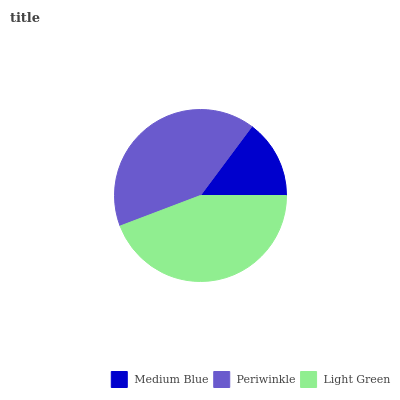Is Medium Blue the minimum?
Answer yes or no. Yes. Is Light Green the maximum?
Answer yes or no. Yes. Is Periwinkle the minimum?
Answer yes or no. No. Is Periwinkle the maximum?
Answer yes or no. No. Is Periwinkle greater than Medium Blue?
Answer yes or no. Yes. Is Medium Blue less than Periwinkle?
Answer yes or no. Yes. Is Medium Blue greater than Periwinkle?
Answer yes or no. No. Is Periwinkle less than Medium Blue?
Answer yes or no. No. Is Periwinkle the high median?
Answer yes or no. Yes. Is Periwinkle the low median?
Answer yes or no. Yes. Is Light Green the high median?
Answer yes or no. No. Is Light Green the low median?
Answer yes or no. No. 